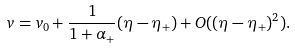<formula> <loc_0><loc_0><loc_500><loc_500>v = v _ { 0 } + \frac { 1 } { 1 + \alpha _ { + } } ( \eta - \eta _ { + } ) + O ( ( \eta - \eta _ { + } ) ^ { 2 } ) .</formula> 